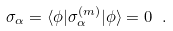<formula> <loc_0><loc_0><loc_500><loc_500>\sigma _ { \alpha } = \langle \phi | \sigma _ { \alpha } ^ { ( m ) } | \phi \rangle = 0 \ .</formula> 